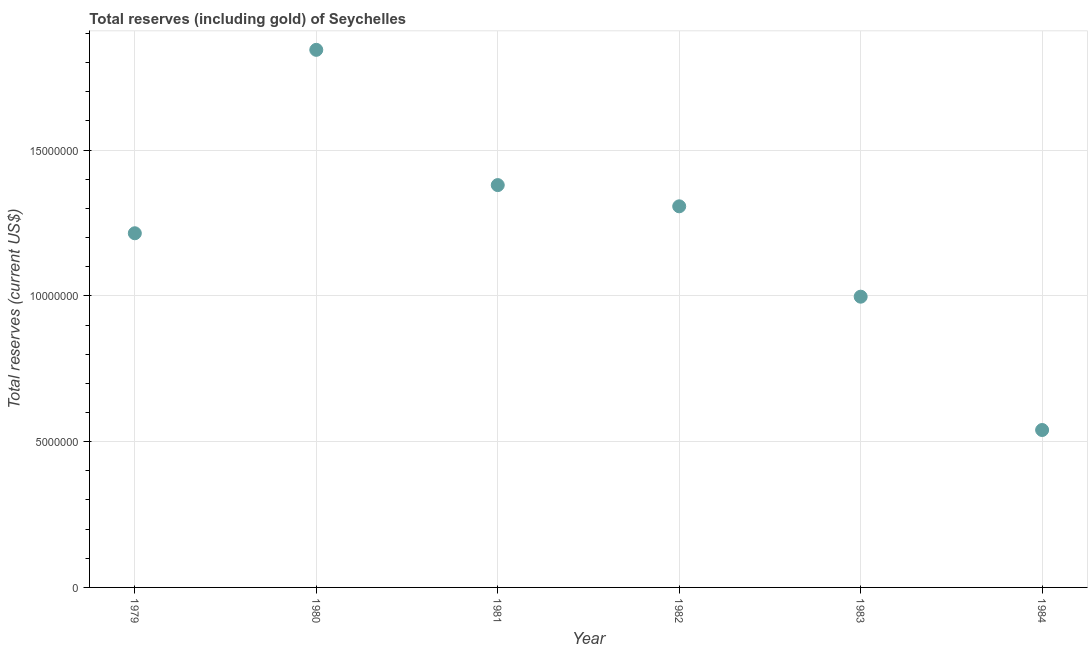What is the total reserves (including gold) in 1982?
Provide a short and direct response. 1.31e+07. Across all years, what is the maximum total reserves (including gold)?
Offer a terse response. 1.84e+07. Across all years, what is the minimum total reserves (including gold)?
Your response must be concise. 5.40e+06. What is the sum of the total reserves (including gold)?
Provide a succinct answer. 7.28e+07. What is the difference between the total reserves (including gold) in 1983 and 1984?
Offer a terse response. 4.57e+06. What is the average total reserves (including gold) per year?
Make the answer very short. 1.21e+07. What is the median total reserves (including gold)?
Give a very brief answer. 1.26e+07. In how many years, is the total reserves (including gold) greater than 15000000 US$?
Offer a very short reply. 1. What is the ratio of the total reserves (including gold) in 1981 to that in 1983?
Provide a short and direct response. 1.38. Is the total reserves (including gold) in 1980 less than that in 1982?
Provide a short and direct response. No. Is the difference between the total reserves (including gold) in 1981 and 1983 greater than the difference between any two years?
Make the answer very short. No. What is the difference between the highest and the second highest total reserves (including gold)?
Your response must be concise. 4.64e+06. What is the difference between the highest and the lowest total reserves (including gold)?
Provide a short and direct response. 1.30e+07. How many dotlines are there?
Your answer should be very brief. 1. What is the title of the graph?
Keep it short and to the point. Total reserves (including gold) of Seychelles. What is the label or title of the X-axis?
Give a very brief answer. Year. What is the label or title of the Y-axis?
Give a very brief answer. Total reserves (current US$). What is the Total reserves (current US$) in 1979?
Provide a short and direct response. 1.21e+07. What is the Total reserves (current US$) in 1980?
Your answer should be compact. 1.84e+07. What is the Total reserves (current US$) in 1981?
Ensure brevity in your answer.  1.38e+07. What is the Total reserves (current US$) in 1982?
Make the answer very short. 1.31e+07. What is the Total reserves (current US$) in 1983?
Make the answer very short. 9.97e+06. What is the Total reserves (current US$) in 1984?
Your answer should be compact. 5.40e+06. What is the difference between the Total reserves (current US$) in 1979 and 1980?
Keep it short and to the point. -6.29e+06. What is the difference between the Total reserves (current US$) in 1979 and 1981?
Give a very brief answer. -1.65e+06. What is the difference between the Total reserves (current US$) in 1979 and 1982?
Provide a succinct answer. -9.24e+05. What is the difference between the Total reserves (current US$) in 1979 and 1983?
Provide a succinct answer. 2.18e+06. What is the difference between the Total reserves (current US$) in 1979 and 1984?
Offer a terse response. 6.75e+06. What is the difference between the Total reserves (current US$) in 1980 and 1981?
Give a very brief answer. 4.64e+06. What is the difference between the Total reserves (current US$) in 1980 and 1982?
Keep it short and to the point. 5.37e+06. What is the difference between the Total reserves (current US$) in 1980 and 1983?
Your response must be concise. 8.47e+06. What is the difference between the Total reserves (current US$) in 1980 and 1984?
Offer a very short reply. 1.30e+07. What is the difference between the Total reserves (current US$) in 1981 and 1982?
Keep it short and to the point. 7.28e+05. What is the difference between the Total reserves (current US$) in 1981 and 1983?
Your response must be concise. 3.83e+06. What is the difference between the Total reserves (current US$) in 1981 and 1984?
Offer a very short reply. 8.40e+06. What is the difference between the Total reserves (current US$) in 1982 and 1983?
Provide a short and direct response. 3.10e+06. What is the difference between the Total reserves (current US$) in 1982 and 1984?
Your response must be concise. 7.67e+06. What is the difference between the Total reserves (current US$) in 1983 and 1984?
Ensure brevity in your answer.  4.57e+06. What is the ratio of the Total reserves (current US$) in 1979 to that in 1980?
Give a very brief answer. 0.66. What is the ratio of the Total reserves (current US$) in 1979 to that in 1981?
Your response must be concise. 0.88. What is the ratio of the Total reserves (current US$) in 1979 to that in 1982?
Your answer should be very brief. 0.93. What is the ratio of the Total reserves (current US$) in 1979 to that in 1983?
Offer a terse response. 1.22. What is the ratio of the Total reserves (current US$) in 1979 to that in 1984?
Give a very brief answer. 2.25. What is the ratio of the Total reserves (current US$) in 1980 to that in 1981?
Provide a short and direct response. 1.34. What is the ratio of the Total reserves (current US$) in 1980 to that in 1982?
Give a very brief answer. 1.41. What is the ratio of the Total reserves (current US$) in 1980 to that in 1983?
Your answer should be very brief. 1.85. What is the ratio of the Total reserves (current US$) in 1980 to that in 1984?
Give a very brief answer. 3.42. What is the ratio of the Total reserves (current US$) in 1981 to that in 1982?
Provide a succinct answer. 1.06. What is the ratio of the Total reserves (current US$) in 1981 to that in 1983?
Provide a short and direct response. 1.38. What is the ratio of the Total reserves (current US$) in 1981 to that in 1984?
Your answer should be very brief. 2.56. What is the ratio of the Total reserves (current US$) in 1982 to that in 1983?
Provide a succinct answer. 1.31. What is the ratio of the Total reserves (current US$) in 1982 to that in 1984?
Offer a very short reply. 2.42. What is the ratio of the Total reserves (current US$) in 1983 to that in 1984?
Your response must be concise. 1.85. 